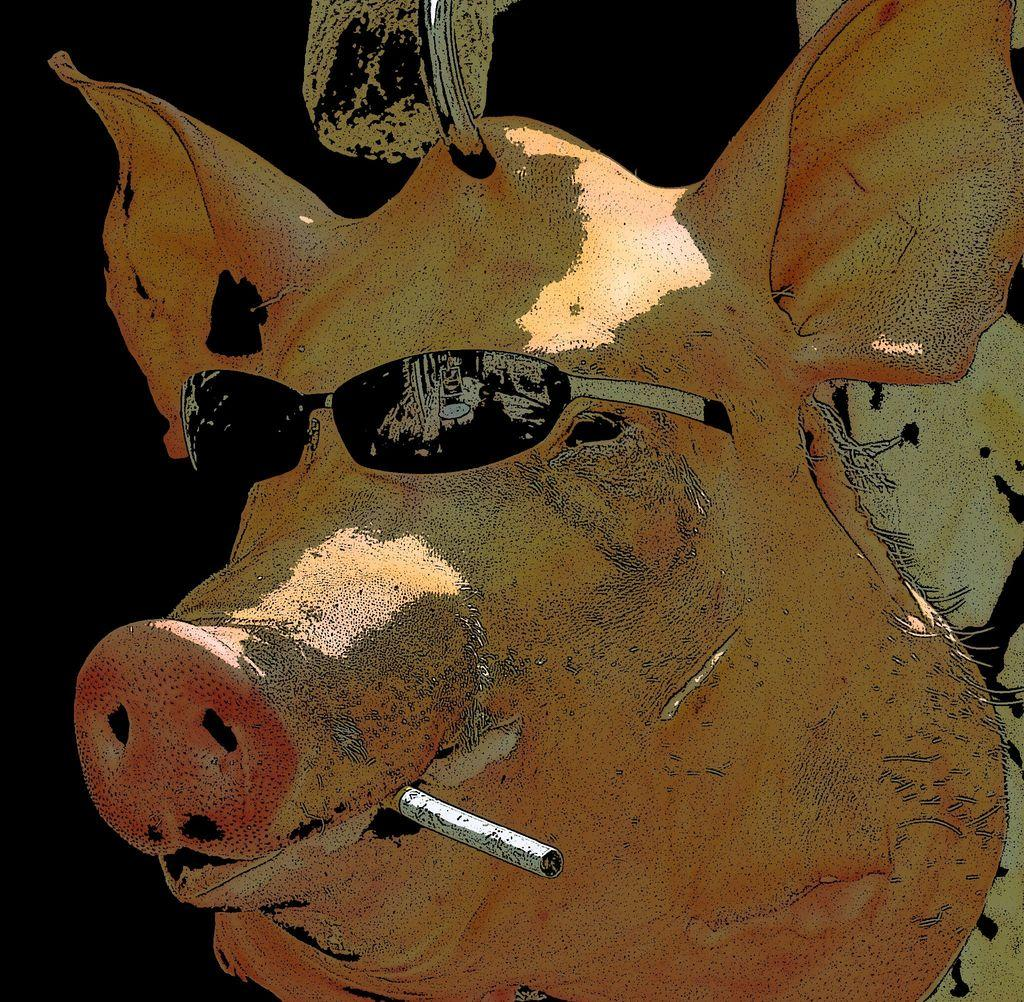What animal is shown in the image? There is a pig depicted in the image. What is the pig wearing? The pig is wearing goggles. What is in the pig's mouth? There is a cigar in the pig's mouth. What is the color of the background in the image? The background of the image is dark. How does the pig's temper affect the other animals in the image? There are no other animals present in the image, so it is impossible to determine the pig's temper or its effect on other animals. 